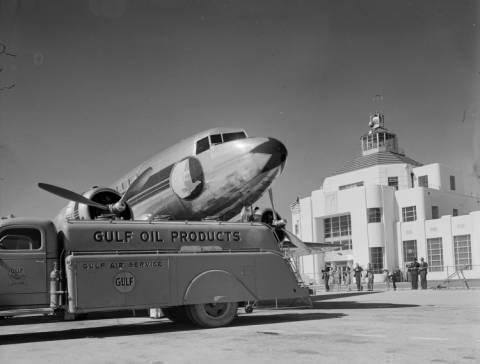How many exhaust pipes does the truck have?
Give a very brief answer. 1. How many plane propellers in this picture?
Give a very brief answer. 2. 